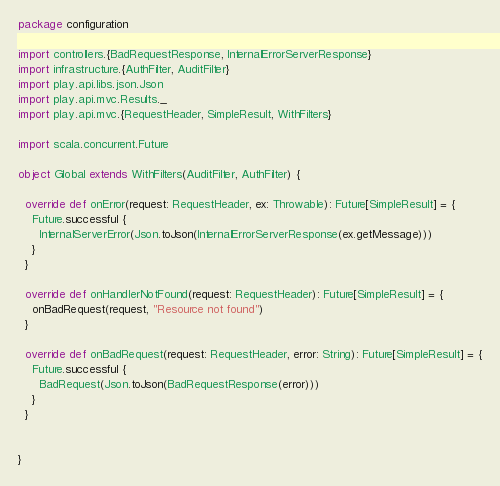<code> <loc_0><loc_0><loc_500><loc_500><_Scala_>package configuration

import controllers.{BadRequestResponse, InternalErrorServerResponse}
import infrastructure.{AuthFilter, AuditFilter}
import play.api.libs.json.Json
import play.api.mvc.Results._
import play.api.mvc.{RequestHeader, SimpleResult, WithFilters}

import scala.concurrent.Future

object Global extends WithFilters(AuditFilter, AuthFilter) {

  override def onError(request: RequestHeader, ex: Throwable): Future[SimpleResult] = {
    Future.successful {
      InternalServerError(Json.toJson(InternalErrorServerResponse(ex.getMessage)))
    }
  }

  override def onHandlerNotFound(request: RequestHeader): Future[SimpleResult] = {
    onBadRequest(request, "Resource not found")
  }

  override def onBadRequest(request: RequestHeader, error: String): Future[SimpleResult] = {
    Future.successful {
      BadRequest(Json.toJson(BadRequestResponse(error)))
    }
  }


}
</code> 